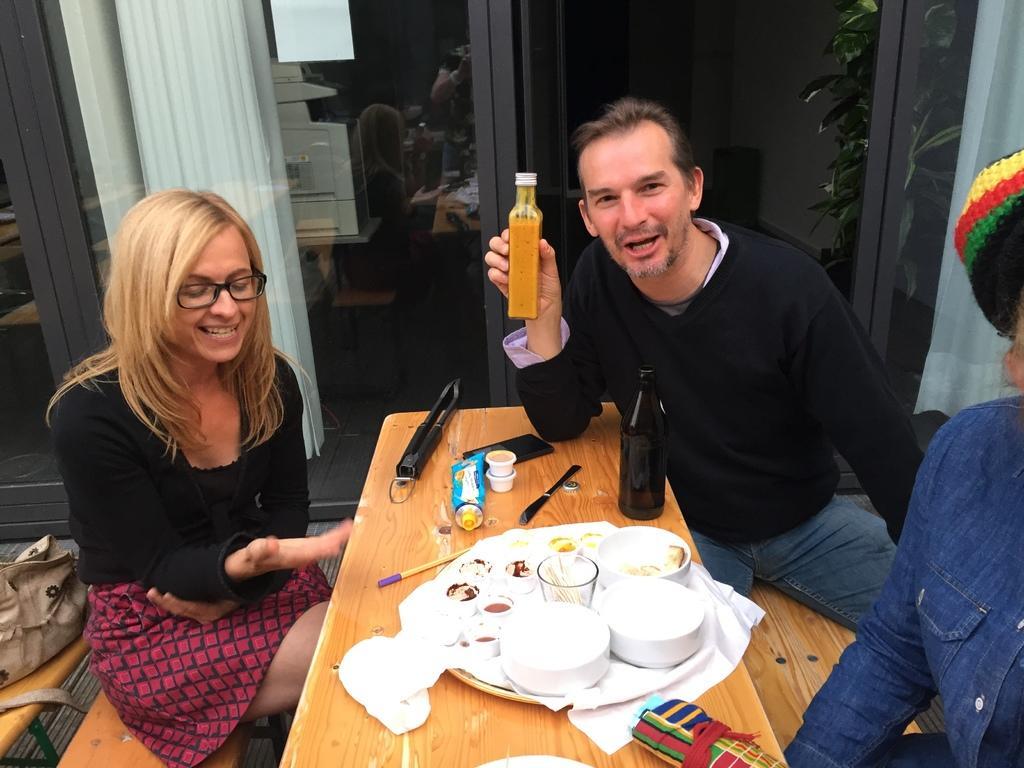In one or two sentences, can you explain what this image depicts? in this image i can see a table. on that , there is a plate, bowl , glass and stationary. at the right there are two people sitting on the bench. the person at the back is wearing black t shirt and holding a bottle. the person at the left is wearing a skirt and a black t shirt. behind them there is a window and a white color curtain 